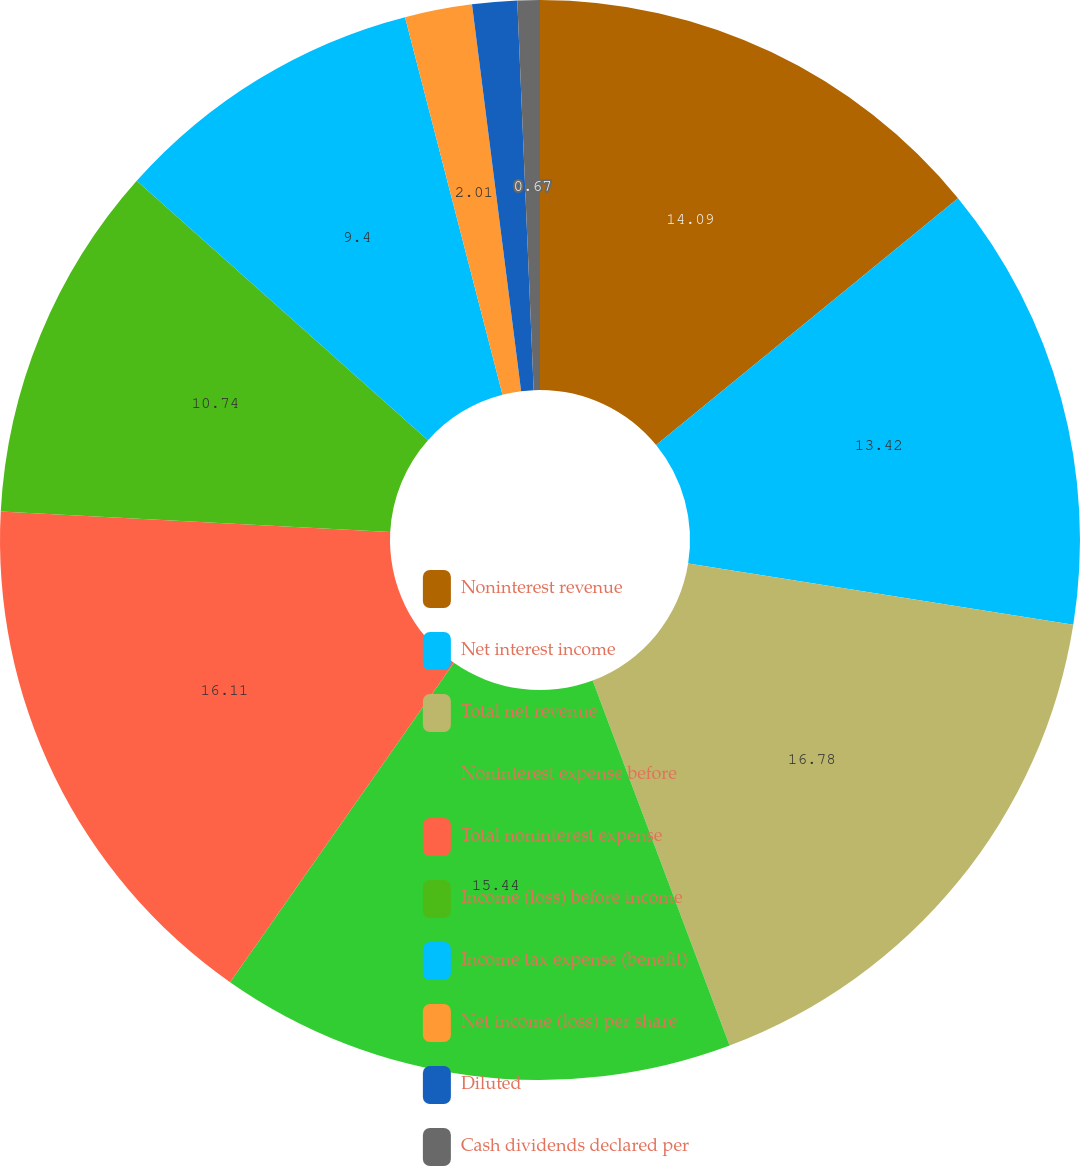Convert chart. <chart><loc_0><loc_0><loc_500><loc_500><pie_chart><fcel>Noninterest revenue<fcel>Net interest income<fcel>Total net revenue<fcel>Noninterest expense before<fcel>Total noninterest expense<fcel>Income (loss) before income<fcel>Income tax expense (benefit)<fcel>Net income (loss) per share<fcel>Diluted<fcel>Cash dividends declared per<nl><fcel>14.09%<fcel>13.42%<fcel>16.78%<fcel>15.44%<fcel>16.11%<fcel>10.74%<fcel>9.4%<fcel>2.01%<fcel>1.34%<fcel>0.67%<nl></chart> 